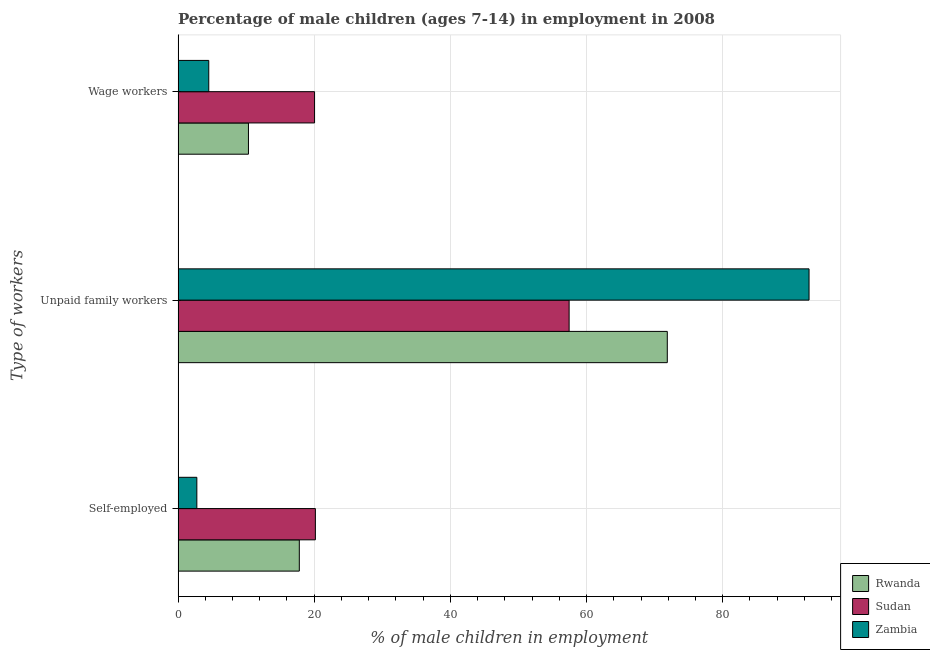How many different coloured bars are there?
Your answer should be very brief. 3. Are the number of bars per tick equal to the number of legend labels?
Ensure brevity in your answer.  Yes. Are the number of bars on each tick of the Y-axis equal?
Offer a very short reply. Yes. How many bars are there on the 2nd tick from the top?
Your answer should be very brief. 3. What is the label of the 2nd group of bars from the top?
Your response must be concise. Unpaid family workers. What is the percentage of children employed as unpaid family workers in Sudan?
Offer a very short reply. 57.44. Across all countries, what is the maximum percentage of children employed as unpaid family workers?
Provide a short and direct response. 92.68. Across all countries, what is the minimum percentage of children employed as unpaid family workers?
Provide a short and direct response. 57.44. In which country was the percentage of children employed as wage workers maximum?
Your answer should be very brief. Sudan. In which country was the percentage of children employed as wage workers minimum?
Offer a terse response. Zambia. What is the total percentage of children employed as unpaid family workers in the graph?
Provide a short and direct response. 221.98. What is the difference between the percentage of children employed as unpaid family workers in Rwanda and that in Zambia?
Your answer should be compact. -20.82. What is the difference between the percentage of children employed as unpaid family workers in Sudan and the percentage of self employed children in Rwanda?
Provide a short and direct response. 39.63. What is the average percentage of self employed children per country?
Your response must be concise. 13.58. What is the difference between the percentage of self employed children and percentage of children employed as unpaid family workers in Rwanda?
Make the answer very short. -54.05. What is the ratio of the percentage of children employed as wage workers in Rwanda to that in Zambia?
Your answer should be compact. 2.29. What is the difference between the highest and the second highest percentage of self employed children?
Make the answer very short. 2.36. What is the difference between the highest and the lowest percentage of children employed as unpaid family workers?
Your answer should be compact. 35.24. In how many countries, is the percentage of self employed children greater than the average percentage of self employed children taken over all countries?
Your answer should be very brief. 2. What does the 3rd bar from the top in Wage workers represents?
Provide a short and direct response. Rwanda. What does the 2nd bar from the bottom in Unpaid family workers represents?
Offer a very short reply. Sudan. How many bars are there?
Make the answer very short. 9. Are all the bars in the graph horizontal?
Provide a short and direct response. Yes. How many countries are there in the graph?
Offer a very short reply. 3. What is the difference between two consecutive major ticks on the X-axis?
Offer a terse response. 20. Are the values on the major ticks of X-axis written in scientific E-notation?
Provide a succinct answer. No. Does the graph contain any zero values?
Make the answer very short. No. How are the legend labels stacked?
Offer a terse response. Vertical. What is the title of the graph?
Ensure brevity in your answer.  Percentage of male children (ages 7-14) in employment in 2008. Does "Central African Republic" appear as one of the legend labels in the graph?
Ensure brevity in your answer.  No. What is the label or title of the X-axis?
Keep it short and to the point. % of male children in employment. What is the label or title of the Y-axis?
Your response must be concise. Type of workers. What is the % of male children in employment in Rwanda in Self-employed?
Offer a terse response. 17.81. What is the % of male children in employment in Sudan in Self-employed?
Offer a terse response. 20.17. What is the % of male children in employment of Zambia in Self-employed?
Your answer should be compact. 2.76. What is the % of male children in employment in Rwanda in Unpaid family workers?
Ensure brevity in your answer.  71.86. What is the % of male children in employment of Sudan in Unpaid family workers?
Your answer should be compact. 57.44. What is the % of male children in employment in Zambia in Unpaid family workers?
Give a very brief answer. 92.68. What is the % of male children in employment in Rwanda in Wage workers?
Offer a terse response. 10.34. What is the % of male children in employment of Sudan in Wage workers?
Make the answer very short. 20.05. What is the % of male children in employment of Zambia in Wage workers?
Make the answer very short. 4.51. Across all Type of workers, what is the maximum % of male children in employment of Rwanda?
Your answer should be compact. 71.86. Across all Type of workers, what is the maximum % of male children in employment in Sudan?
Make the answer very short. 57.44. Across all Type of workers, what is the maximum % of male children in employment of Zambia?
Provide a succinct answer. 92.68. Across all Type of workers, what is the minimum % of male children in employment in Rwanda?
Keep it short and to the point. 10.34. Across all Type of workers, what is the minimum % of male children in employment in Sudan?
Offer a very short reply. 20.05. Across all Type of workers, what is the minimum % of male children in employment of Zambia?
Provide a succinct answer. 2.76. What is the total % of male children in employment in Rwanda in the graph?
Make the answer very short. 100.01. What is the total % of male children in employment in Sudan in the graph?
Offer a terse response. 97.66. What is the total % of male children in employment of Zambia in the graph?
Give a very brief answer. 99.95. What is the difference between the % of male children in employment of Rwanda in Self-employed and that in Unpaid family workers?
Give a very brief answer. -54.05. What is the difference between the % of male children in employment of Sudan in Self-employed and that in Unpaid family workers?
Make the answer very short. -37.27. What is the difference between the % of male children in employment of Zambia in Self-employed and that in Unpaid family workers?
Ensure brevity in your answer.  -89.92. What is the difference between the % of male children in employment of Rwanda in Self-employed and that in Wage workers?
Make the answer very short. 7.47. What is the difference between the % of male children in employment in Sudan in Self-employed and that in Wage workers?
Provide a succinct answer. 0.12. What is the difference between the % of male children in employment of Zambia in Self-employed and that in Wage workers?
Offer a terse response. -1.75. What is the difference between the % of male children in employment of Rwanda in Unpaid family workers and that in Wage workers?
Your answer should be compact. 61.52. What is the difference between the % of male children in employment of Sudan in Unpaid family workers and that in Wage workers?
Ensure brevity in your answer.  37.39. What is the difference between the % of male children in employment of Zambia in Unpaid family workers and that in Wage workers?
Keep it short and to the point. 88.17. What is the difference between the % of male children in employment in Rwanda in Self-employed and the % of male children in employment in Sudan in Unpaid family workers?
Your response must be concise. -39.63. What is the difference between the % of male children in employment in Rwanda in Self-employed and the % of male children in employment in Zambia in Unpaid family workers?
Offer a terse response. -74.87. What is the difference between the % of male children in employment in Sudan in Self-employed and the % of male children in employment in Zambia in Unpaid family workers?
Your answer should be very brief. -72.51. What is the difference between the % of male children in employment of Rwanda in Self-employed and the % of male children in employment of Sudan in Wage workers?
Offer a very short reply. -2.24. What is the difference between the % of male children in employment in Sudan in Self-employed and the % of male children in employment in Zambia in Wage workers?
Make the answer very short. 15.66. What is the difference between the % of male children in employment in Rwanda in Unpaid family workers and the % of male children in employment in Sudan in Wage workers?
Your response must be concise. 51.81. What is the difference between the % of male children in employment in Rwanda in Unpaid family workers and the % of male children in employment in Zambia in Wage workers?
Give a very brief answer. 67.35. What is the difference between the % of male children in employment in Sudan in Unpaid family workers and the % of male children in employment in Zambia in Wage workers?
Offer a terse response. 52.93. What is the average % of male children in employment of Rwanda per Type of workers?
Give a very brief answer. 33.34. What is the average % of male children in employment in Sudan per Type of workers?
Make the answer very short. 32.55. What is the average % of male children in employment in Zambia per Type of workers?
Offer a very short reply. 33.32. What is the difference between the % of male children in employment in Rwanda and % of male children in employment in Sudan in Self-employed?
Ensure brevity in your answer.  -2.36. What is the difference between the % of male children in employment in Rwanda and % of male children in employment in Zambia in Self-employed?
Your response must be concise. 15.05. What is the difference between the % of male children in employment of Sudan and % of male children in employment of Zambia in Self-employed?
Your answer should be compact. 17.41. What is the difference between the % of male children in employment in Rwanda and % of male children in employment in Sudan in Unpaid family workers?
Provide a short and direct response. 14.42. What is the difference between the % of male children in employment in Rwanda and % of male children in employment in Zambia in Unpaid family workers?
Provide a short and direct response. -20.82. What is the difference between the % of male children in employment in Sudan and % of male children in employment in Zambia in Unpaid family workers?
Make the answer very short. -35.24. What is the difference between the % of male children in employment in Rwanda and % of male children in employment in Sudan in Wage workers?
Offer a terse response. -9.71. What is the difference between the % of male children in employment of Rwanda and % of male children in employment of Zambia in Wage workers?
Offer a very short reply. 5.83. What is the difference between the % of male children in employment of Sudan and % of male children in employment of Zambia in Wage workers?
Offer a terse response. 15.54. What is the ratio of the % of male children in employment in Rwanda in Self-employed to that in Unpaid family workers?
Give a very brief answer. 0.25. What is the ratio of the % of male children in employment of Sudan in Self-employed to that in Unpaid family workers?
Your answer should be compact. 0.35. What is the ratio of the % of male children in employment in Zambia in Self-employed to that in Unpaid family workers?
Offer a very short reply. 0.03. What is the ratio of the % of male children in employment of Rwanda in Self-employed to that in Wage workers?
Ensure brevity in your answer.  1.72. What is the ratio of the % of male children in employment in Sudan in Self-employed to that in Wage workers?
Offer a terse response. 1.01. What is the ratio of the % of male children in employment in Zambia in Self-employed to that in Wage workers?
Ensure brevity in your answer.  0.61. What is the ratio of the % of male children in employment of Rwanda in Unpaid family workers to that in Wage workers?
Provide a succinct answer. 6.95. What is the ratio of the % of male children in employment in Sudan in Unpaid family workers to that in Wage workers?
Make the answer very short. 2.86. What is the ratio of the % of male children in employment of Zambia in Unpaid family workers to that in Wage workers?
Make the answer very short. 20.55. What is the difference between the highest and the second highest % of male children in employment in Rwanda?
Your answer should be very brief. 54.05. What is the difference between the highest and the second highest % of male children in employment of Sudan?
Offer a very short reply. 37.27. What is the difference between the highest and the second highest % of male children in employment of Zambia?
Provide a succinct answer. 88.17. What is the difference between the highest and the lowest % of male children in employment of Rwanda?
Offer a very short reply. 61.52. What is the difference between the highest and the lowest % of male children in employment in Sudan?
Provide a succinct answer. 37.39. What is the difference between the highest and the lowest % of male children in employment in Zambia?
Your answer should be very brief. 89.92. 